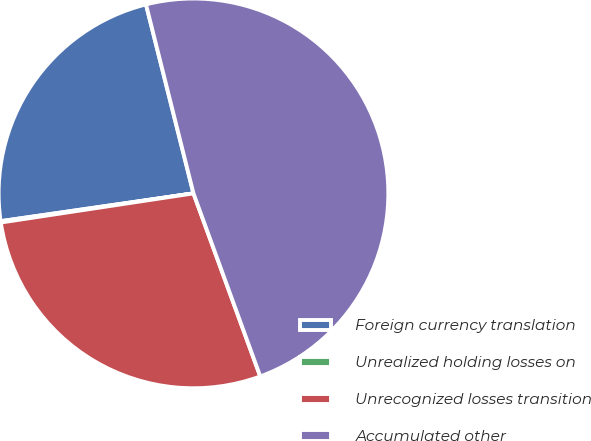<chart> <loc_0><loc_0><loc_500><loc_500><pie_chart><fcel>Foreign currency translation<fcel>Unrealized holding losses on<fcel>Unrecognized losses transition<fcel>Accumulated other<nl><fcel>23.36%<fcel>0.11%<fcel>28.18%<fcel>48.35%<nl></chart> 